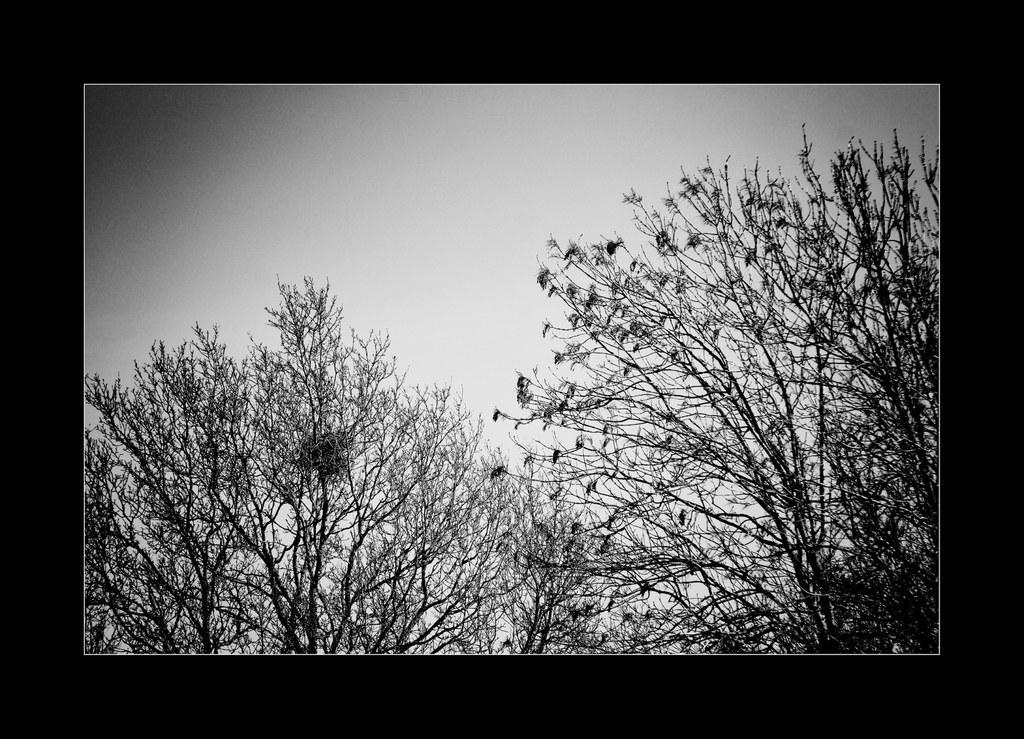What type of photograph is in the image? The image contains a black and white photograph. What is the subject of the photograph? The photograph depicts dry trees. What type of car is visible in the image? There is no car present in the image; it only contains a black and white photograph of dry trees. 